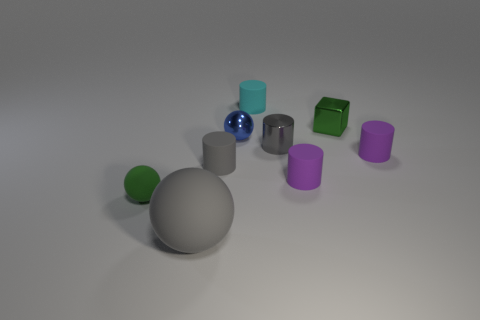Subtract all cyan cylinders. How many cylinders are left? 4 Subtract all tiny cyan cylinders. How many cylinders are left? 4 Subtract all blue cylinders. Subtract all cyan blocks. How many cylinders are left? 5 Subtract all cylinders. How many objects are left? 4 Subtract all small purple cylinders. Subtract all shiny spheres. How many objects are left? 6 Add 6 small cyan objects. How many small cyan objects are left? 7 Add 4 large balls. How many large balls exist? 5 Subtract 0 blue blocks. How many objects are left? 9 